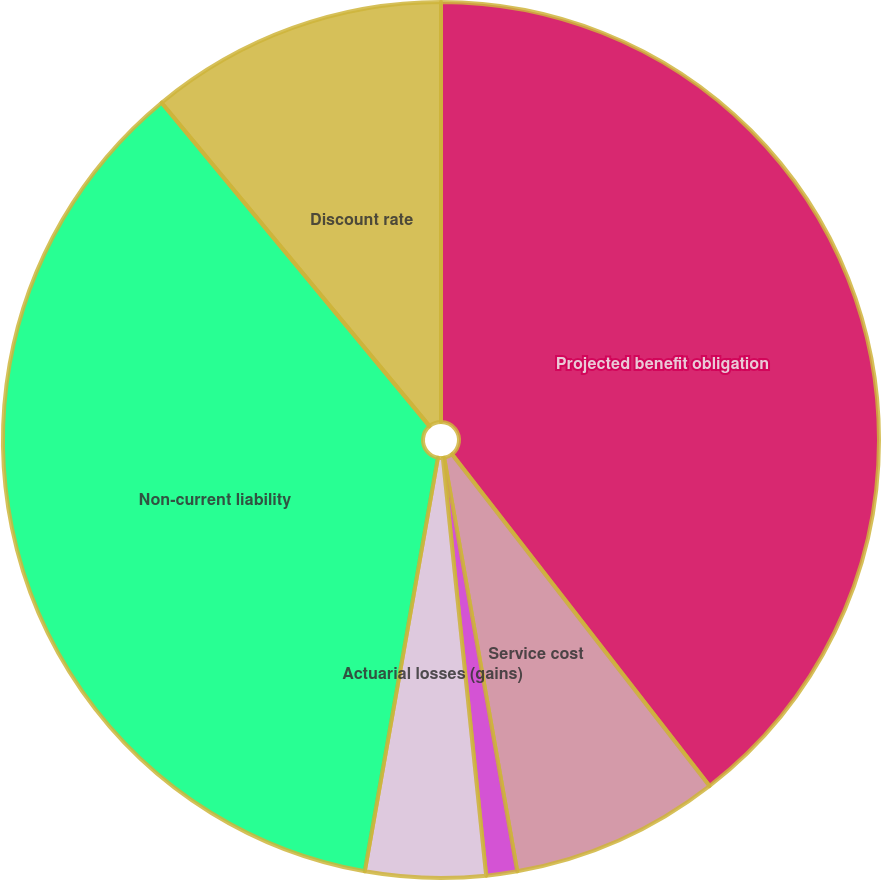<chart> <loc_0><loc_0><loc_500><loc_500><pie_chart><fcel>Projected benefit obligation<fcel>Service cost<fcel>Interest cost<fcel>Actuarial losses (gains)<fcel>Non-current liability<fcel>Discount rate<nl><fcel>39.5%<fcel>7.72%<fcel>1.14%<fcel>4.43%<fcel>36.21%<fcel>11.01%<nl></chart> 